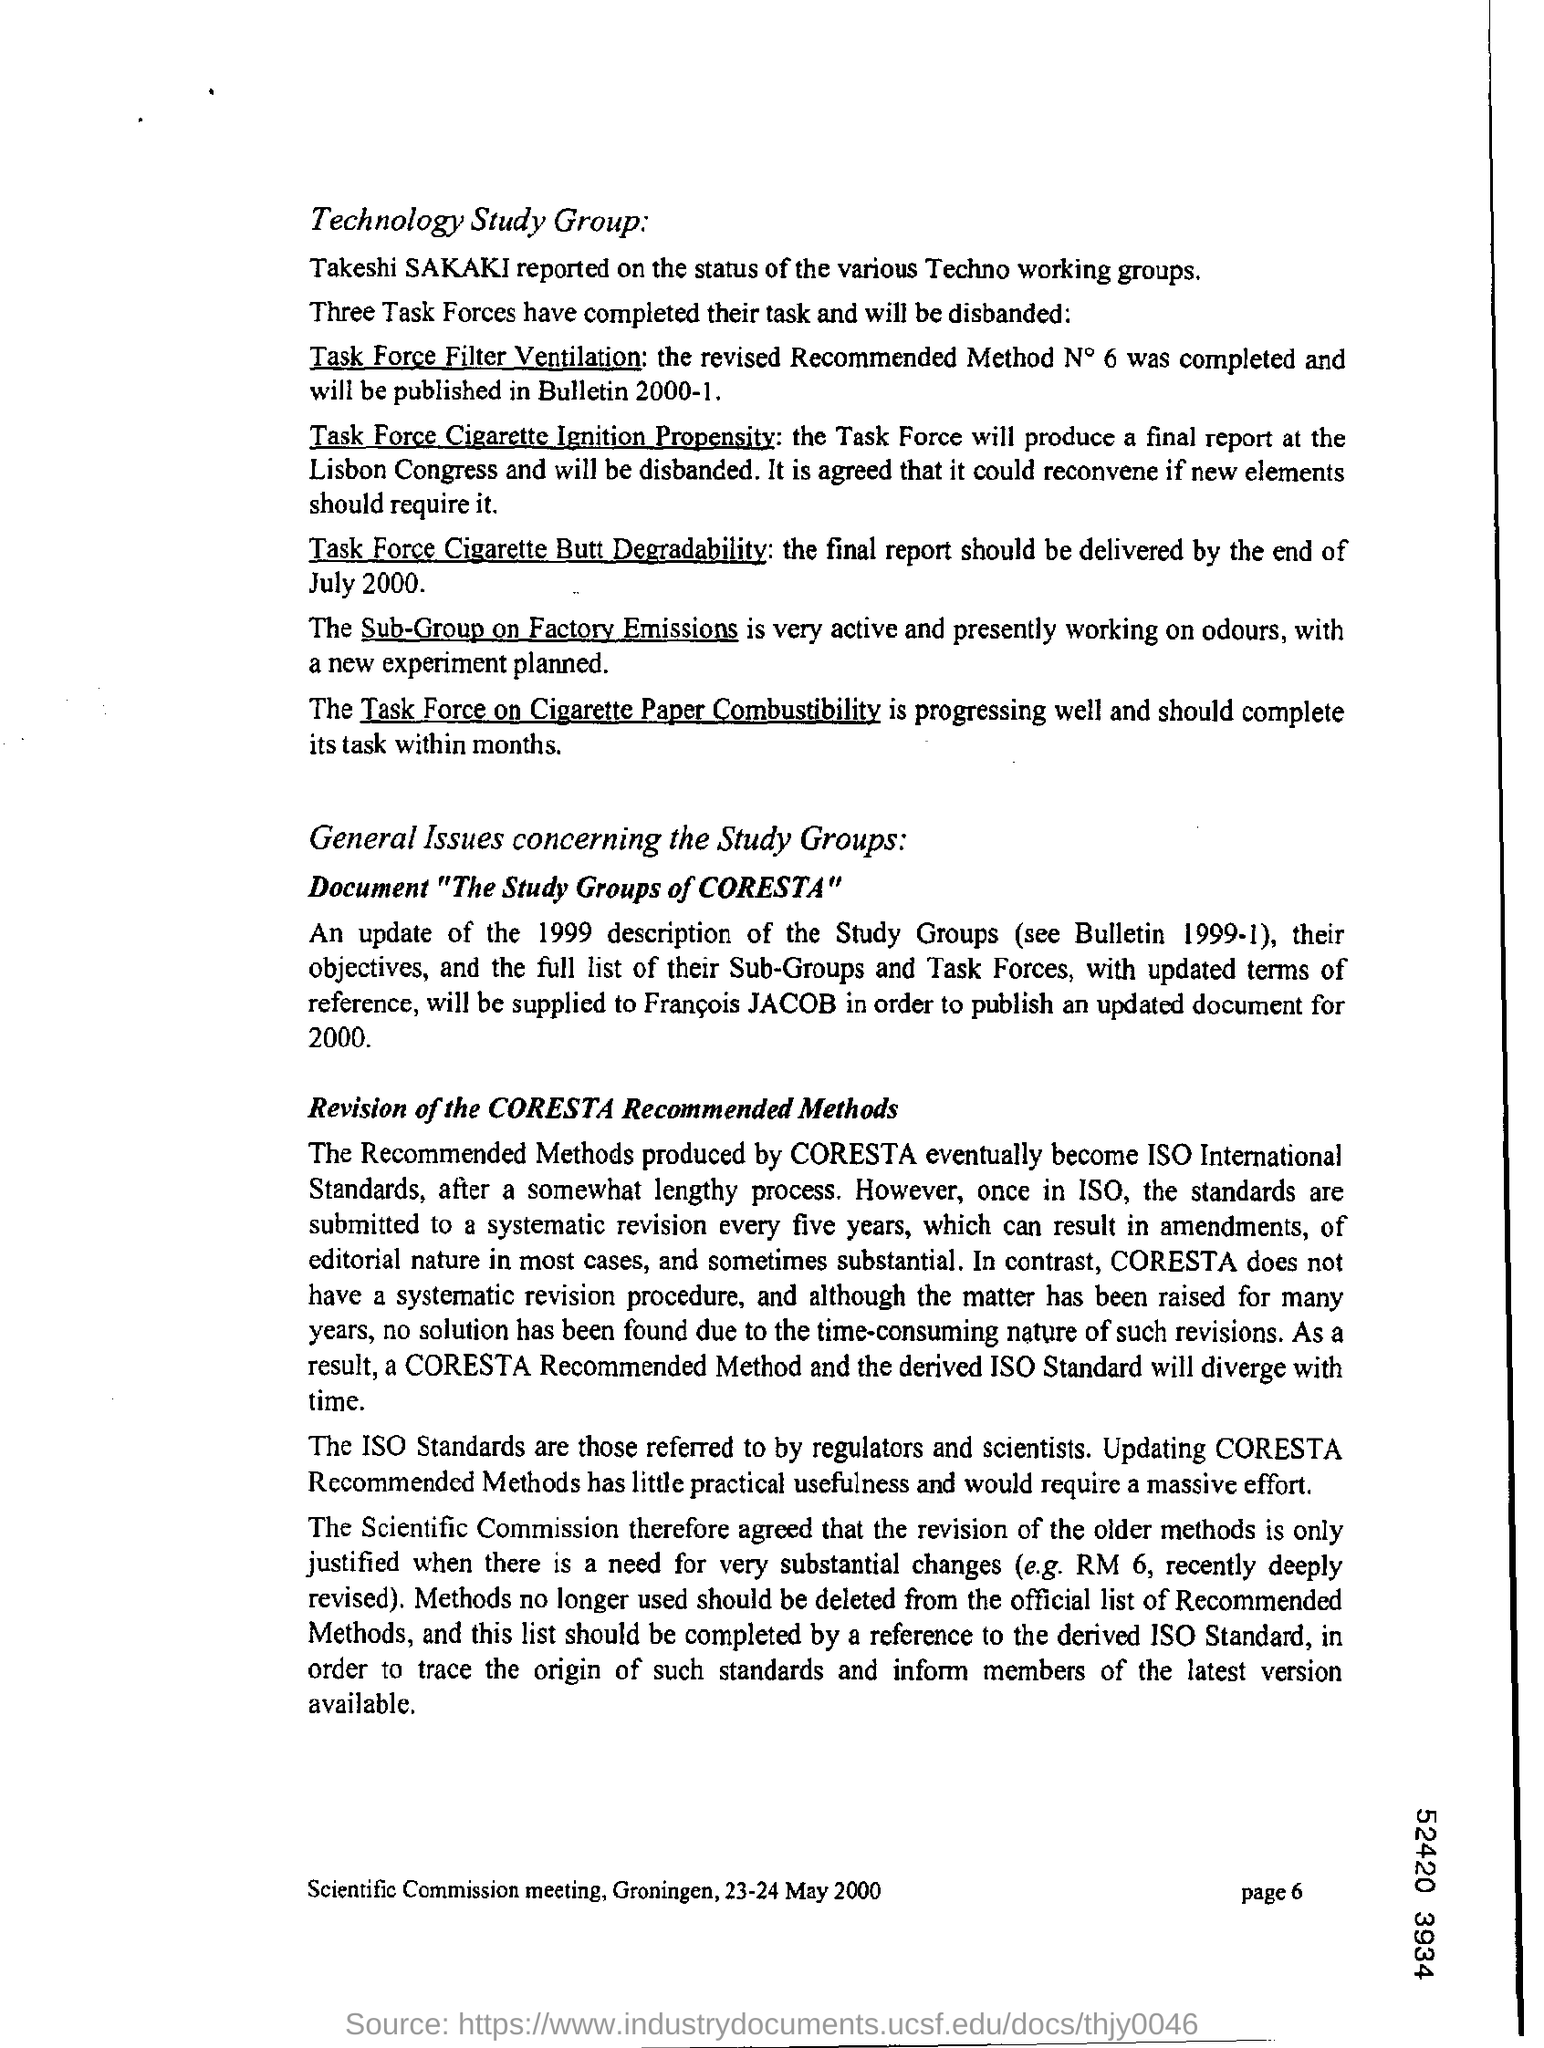Identify some key points in this picture. Mention the page number at the bottom right corner of the page starting from page 6. 